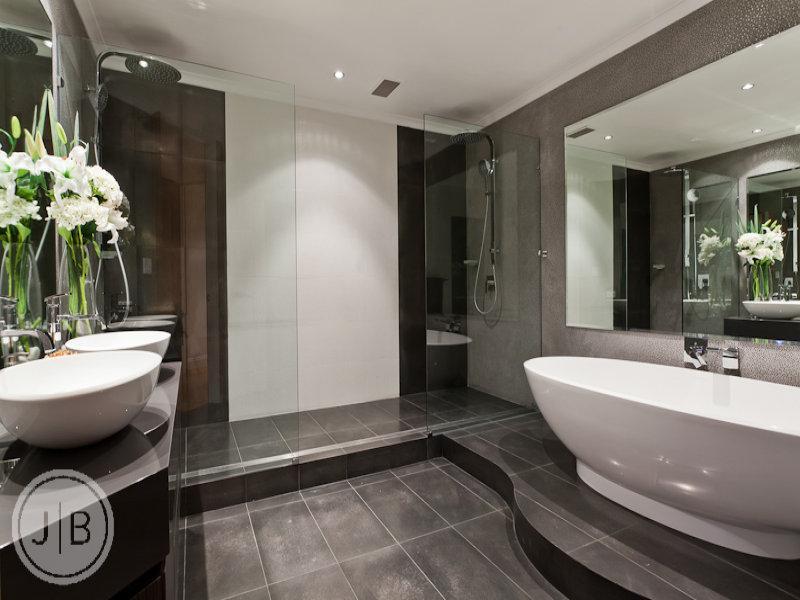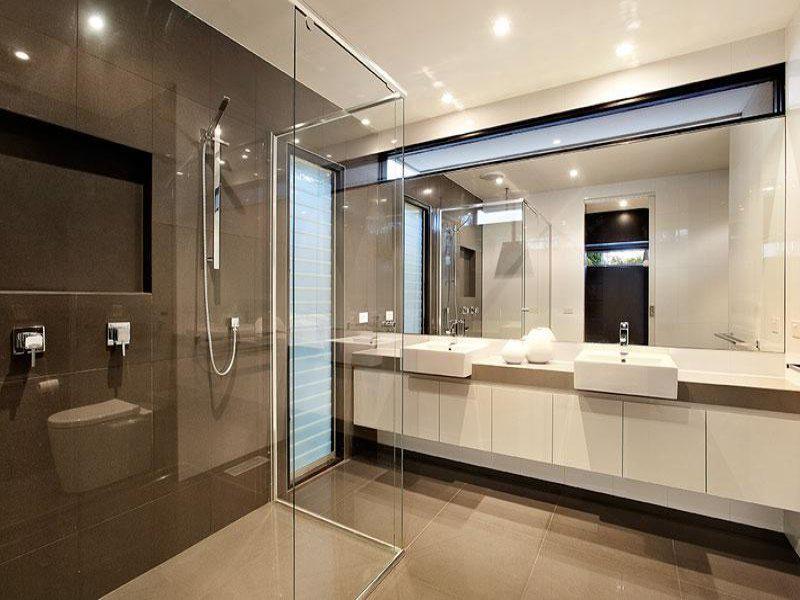The first image is the image on the left, the second image is the image on the right. Considering the images on both sides, is "Three or more sinks are visible." valid? Answer yes or no. Yes. The first image is the image on the left, the second image is the image on the right. Analyze the images presented: Is the assertion "There is exactly one sink." valid? Answer yes or no. No. 